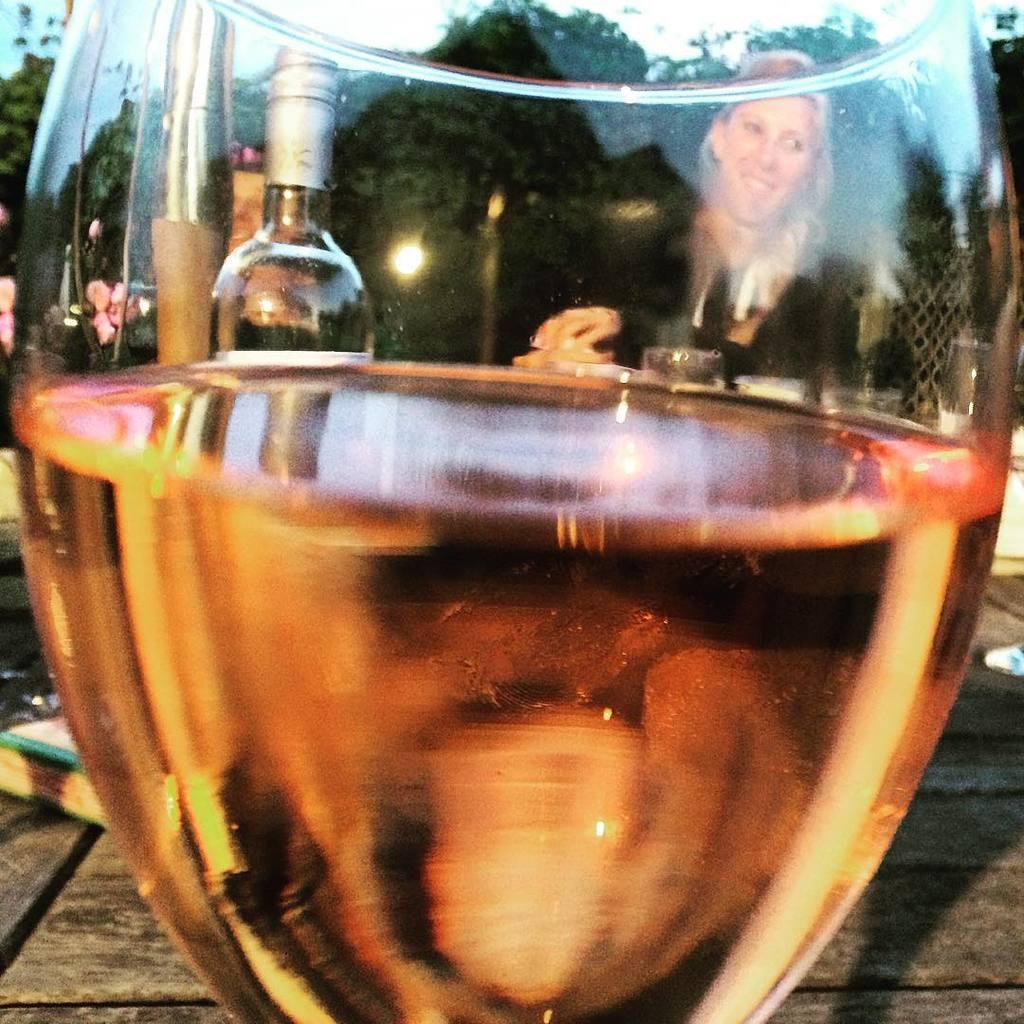What is the woman doing in the image? The woman is seated in the image. What is present on the table with the woman? There is a wine glass and wine bottles on the table. Can you describe the objects on the table? The objects on the table are a wine glass and wine bottles. What type of chess pieces can be seen on the table in the image? There are no chess pieces present in the image. How many ducks are visible in the image? There are no ducks visible in the image. 